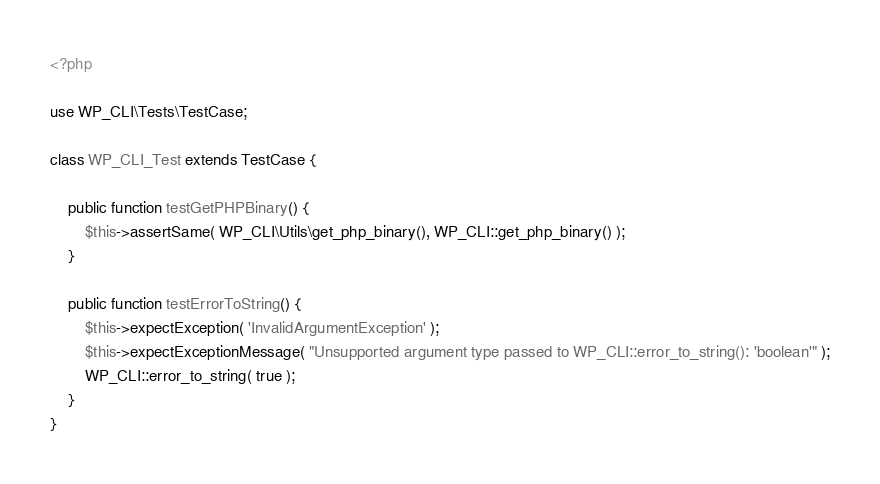Convert code to text. <code><loc_0><loc_0><loc_500><loc_500><_PHP_><?php

use WP_CLI\Tests\TestCase;

class WP_CLI_Test extends TestCase {

	public function testGetPHPBinary() {
		$this->assertSame( WP_CLI\Utils\get_php_binary(), WP_CLI::get_php_binary() );
	}

	public function testErrorToString() {
		$this->expectException( 'InvalidArgumentException' );
		$this->expectExceptionMessage( "Unsupported argument type passed to WP_CLI::error_to_string(): 'boolean'" );
		WP_CLI::error_to_string( true );
	}
}
</code> 